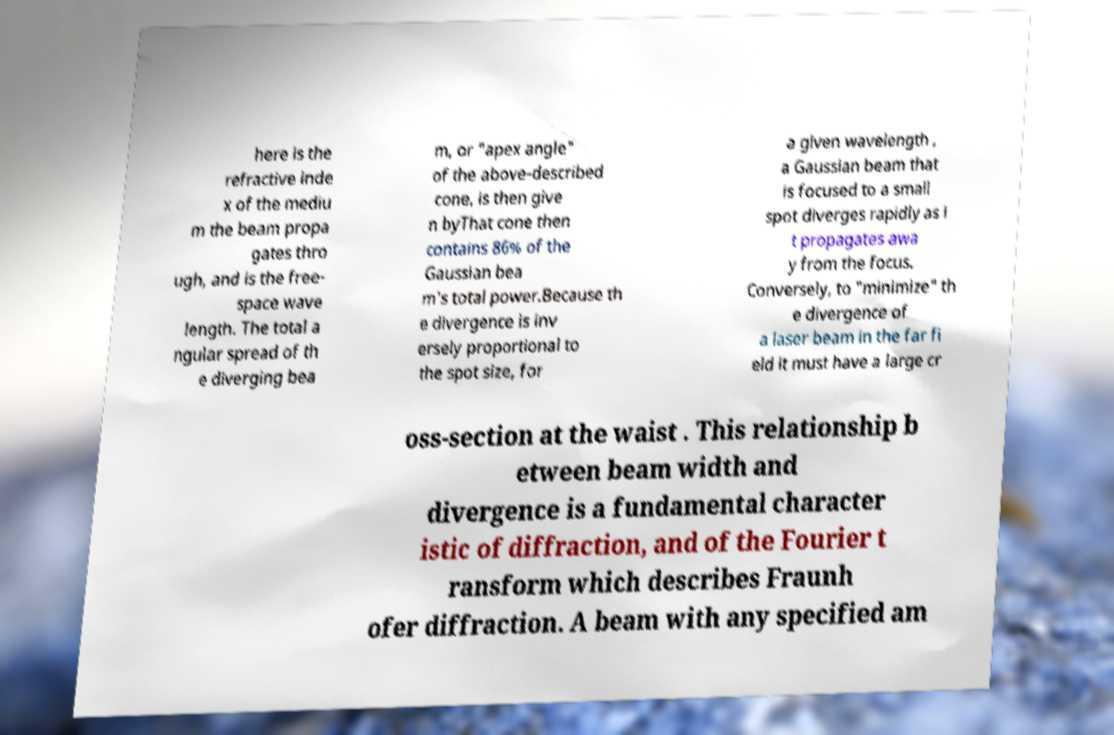Please identify and transcribe the text found in this image. here is the refractive inde x of the mediu m the beam propa gates thro ugh, and is the free- space wave length. The total a ngular spread of th e diverging bea m, or "apex angle" of the above-described cone, is then give n byThat cone then contains 86% of the Gaussian bea m's total power.Because th e divergence is inv ersely proportional to the spot size, for a given wavelength , a Gaussian beam that is focused to a small spot diverges rapidly as i t propagates awa y from the focus. Conversely, to "minimize" th e divergence of a laser beam in the far fi eld it must have a large cr oss-section at the waist . This relationship b etween beam width and divergence is a fundamental character istic of diffraction, and of the Fourier t ransform which describes Fraunh ofer diffraction. A beam with any specified am 